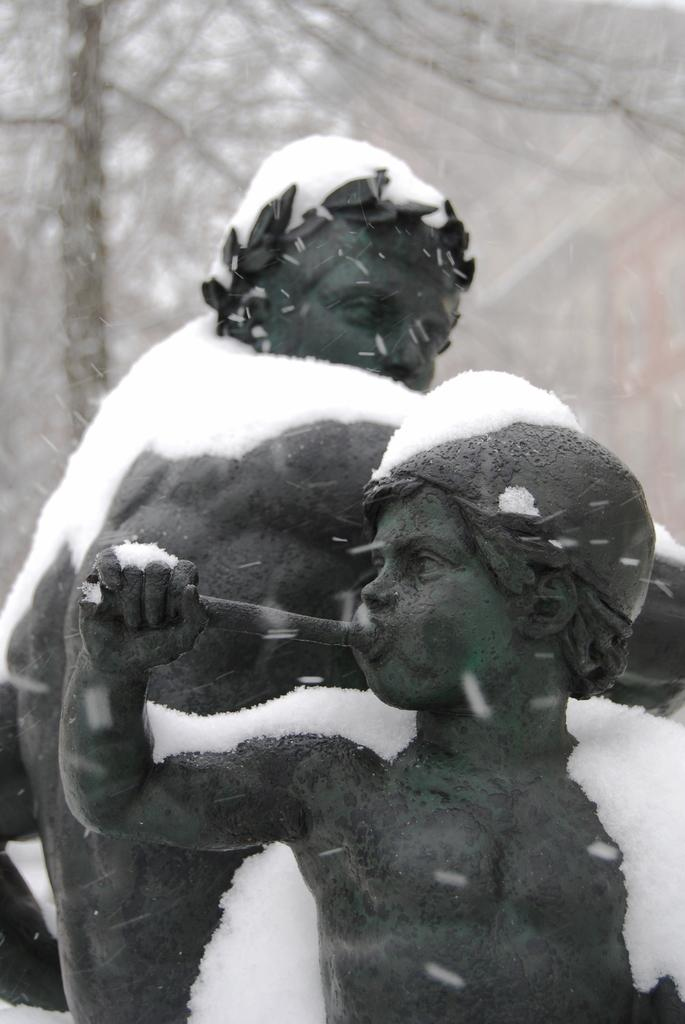What type of artwork can be seen in the image? There are sculptures in the image. What is the weather like in the image? There is snow visible in the image, indicating a cold or wintry environment. What can be seen in the background of the image? There are trees in the background of the image. What type of glove is being worn by the sculpture in the image? There are no gloves present in the image, as the subject is a sculpture and not a person wearing clothing. 